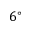<formula> <loc_0><loc_0><loc_500><loc_500>6 ^ { \circ }</formula> 